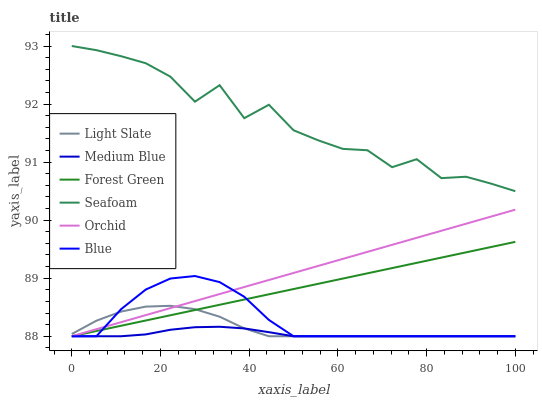Does Medium Blue have the minimum area under the curve?
Answer yes or no. Yes. Does Seafoam have the maximum area under the curve?
Answer yes or no. Yes. Does Light Slate have the minimum area under the curve?
Answer yes or no. No. Does Light Slate have the maximum area under the curve?
Answer yes or no. No. Is Orchid the smoothest?
Answer yes or no. Yes. Is Seafoam the roughest?
Answer yes or no. Yes. Is Light Slate the smoothest?
Answer yes or no. No. Is Light Slate the roughest?
Answer yes or no. No. Does Blue have the lowest value?
Answer yes or no. Yes. Does Seafoam have the lowest value?
Answer yes or no. No. Does Seafoam have the highest value?
Answer yes or no. Yes. Does Light Slate have the highest value?
Answer yes or no. No. Is Medium Blue less than Seafoam?
Answer yes or no. Yes. Is Seafoam greater than Forest Green?
Answer yes or no. Yes. Does Light Slate intersect Orchid?
Answer yes or no. Yes. Is Light Slate less than Orchid?
Answer yes or no. No. Is Light Slate greater than Orchid?
Answer yes or no. No. Does Medium Blue intersect Seafoam?
Answer yes or no. No. 